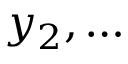<formula> <loc_0><loc_0><loc_500><loc_500>y _ { 2 } , \dots</formula> 